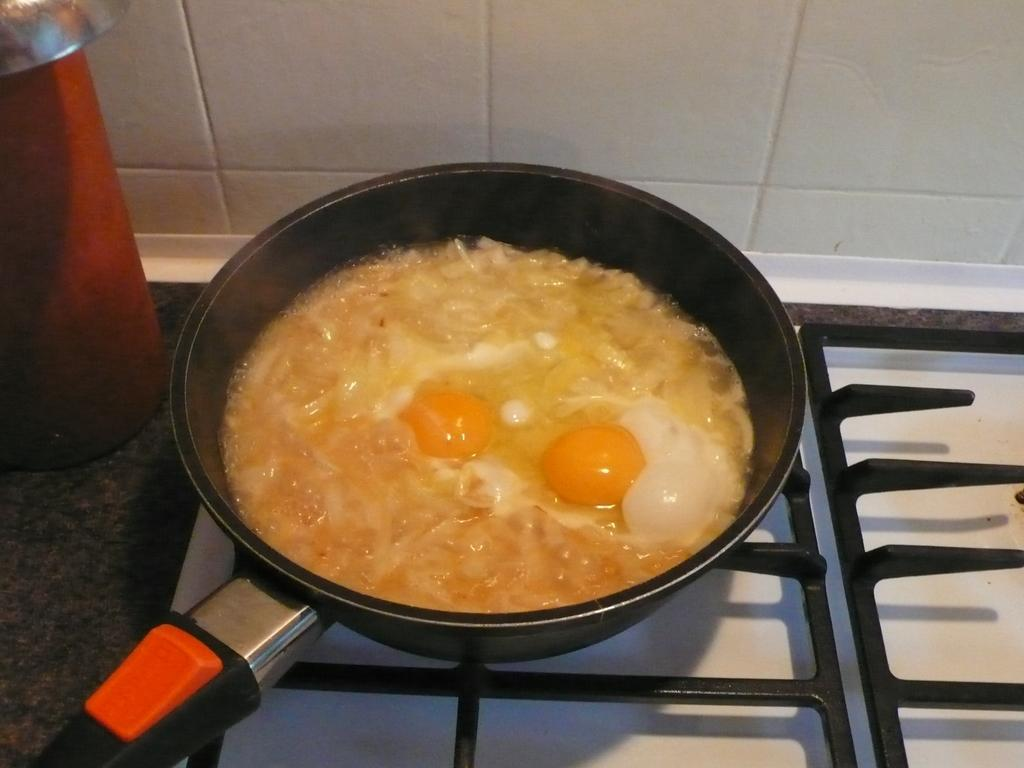What is in the pan that is visible in the image? Eggs and onions are present in the pan. What color is the red object to the left side of the image? The provided facts do not mention the color of the red object. What is the source of heat for cooking the food in the pan? A stove is visible at the bottom of the image. How much income does the person celebrating their birthday in the image earn? There is no information about income or a birthday celebration in the image. 